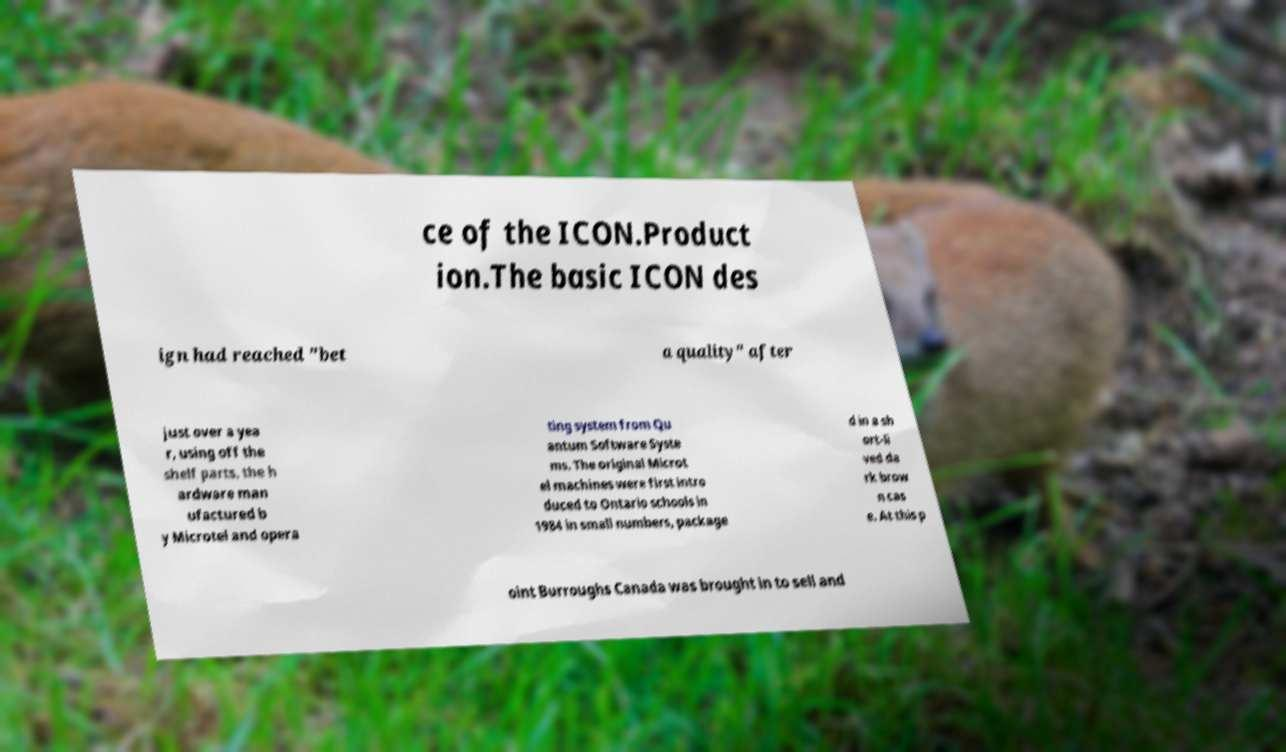What messages or text are displayed in this image? I need them in a readable, typed format. ce of the ICON.Product ion.The basic ICON des ign had reached "bet a quality" after just over a yea r, using off the shelf parts, the h ardware man ufactured b y Microtel and opera ting system from Qu antum Software Syste ms. The original Microt el machines were first intro duced to Ontario schools in 1984 in small numbers, package d in a sh ort-li ved da rk brow n cas e. At this p oint Burroughs Canada was brought in to sell and 